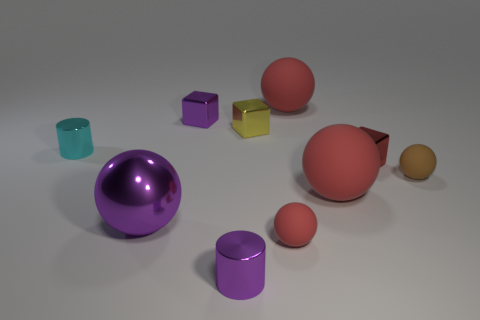Can you describe the different shapes and colors present in the image? Certainly! The image features an assortment of geometric objects. There's a large purple sphere, a small and a large crimson sphere, and a tiny ochre sphere. We also see a cyan cylinder, a magenta cube, and a small yellow cube. The diversity in shapes and colors creates a visually intriguing scene. 